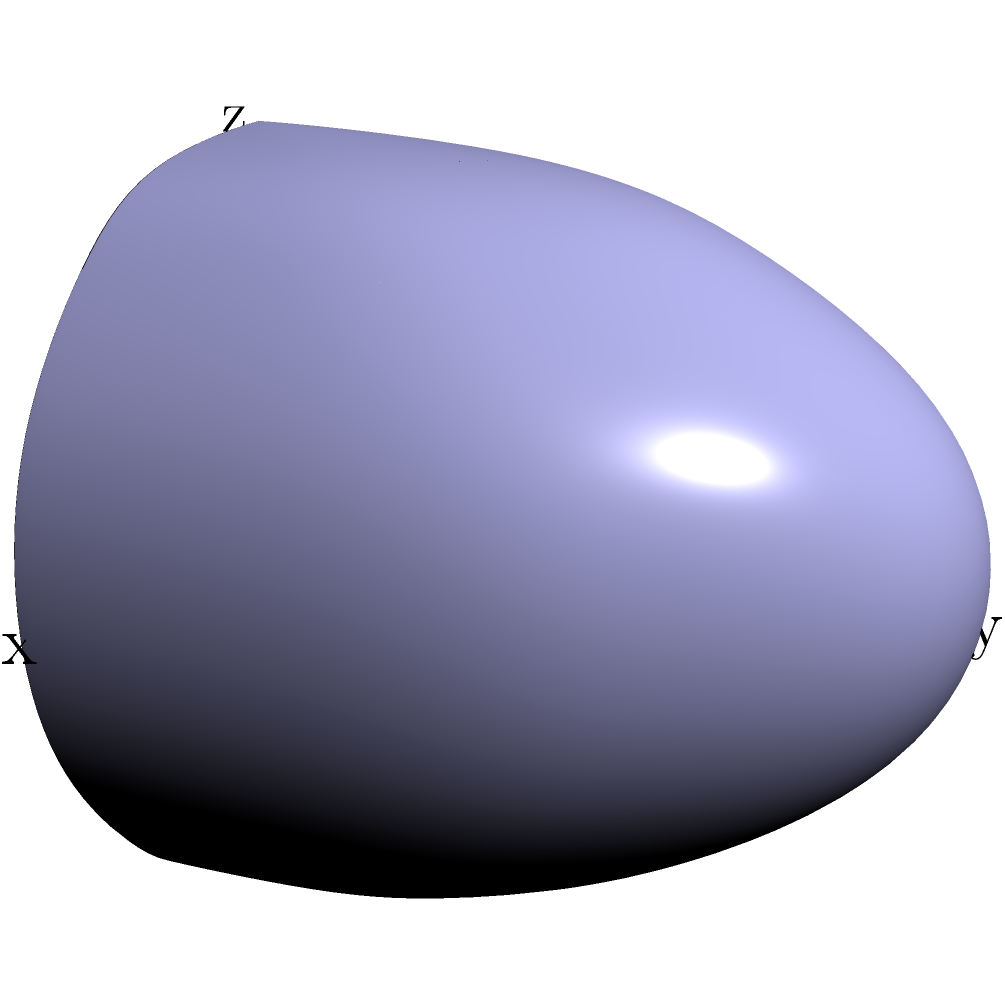As a dedicated Lions fan, you're designing a new helmet for the team. The shape of the helmet can be approximated by the upper half of a sphere with radius 2 feet. Using multivariable calculus, calculate the volume of this helmet. The surface of the helmet is given by the function $f(x, y, z) = x^2 + y^2 + z^2 = 4$ for $z \geq 0$. Express your answer in cubic feet and round to two decimal places. Let's approach this step-by-step:

1) We need to set up a triple integral to calculate the volume. In spherical coordinates, the volume element is $dV = r^2 \sin(\phi) dr d\phi d\theta$.

2) The limits of integration will be:
   $r$: from 0 to 2 (radius of the sphere)
   $\phi$: from 0 to $\pi/2$ (we only want the upper half of the sphere)
   $\theta$: from 0 to $2\pi$ (full rotation around the z-axis)

3) The integral will be:

   $$V = \int_0^{2\pi} \int_0^{\pi/2} \int_0^2 r^2 \sin(\phi) dr d\phi d\theta$$

4) Let's solve the integral:

   $$V = \int_0^{2\pi} \int_0^{\pi/2} [\frac{1}{3}r^3]_0^2 \sin(\phi) d\phi d\theta$$
   
   $$= \int_0^{2\pi} \int_0^{\pi/2} \frac{8}{3} \sin(\phi) d\phi d\theta$$
   
   $$= \int_0^{2\pi} \frac{8}{3} [-\cos(\phi)]_0^{\pi/2} d\theta$$
   
   $$= \int_0^{2\pi} \frac{8}{3} d\theta$$
   
   $$= [\frac{8}{3}\theta]_0^{2\pi} = \frac{16\pi}{3}$$

5) $\frac{16\pi}{3} \approx 16.76$ cubic feet

Rounding to two decimal places, we get 16.76 cubic feet.
Answer: 16.76 cubic feet 